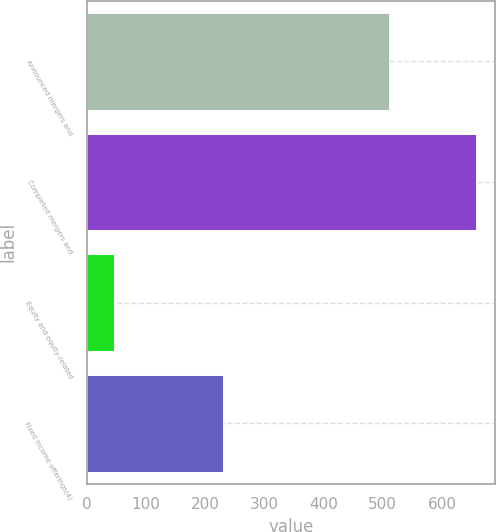Convert chart. <chart><loc_0><loc_0><loc_500><loc_500><bar_chart><fcel>Announced mergers and<fcel>Completed mergers and<fcel>Equity and equity-related<fcel>Fixed income offerings(4)<nl><fcel>510<fcel>657<fcel>47<fcel>231<nl></chart> 